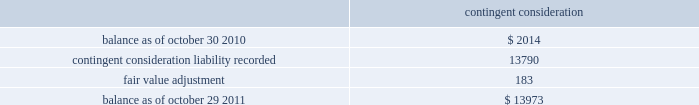( 2 ) the company has a master netting arrangement by counterparty with respect to derivative contracts .
As of october 29 , 2011 and october 30 , 2010 , contracts in a liability position of $ 0.8 million in each year , were netted against contracts in an asset position in the consolidated balance sheets .
( 3 ) equal to the accreted notional value of the debt plus the fair value of the interest rate component of the long- term debt .
The fair value of the long-term debt as of october 29 , 2011 and october 30 , 2010 was $ 413.4 million and $ 416.3 million , respectively .
The following methods and assumptions were used by the company in estimating its fair value disclosures for financial instruments : cash equivalents and short-term investments 2014 these investments are adjusted to fair value based on quoted market prices or are determined using a yield curve model based on current market rates .
Deferred compensation plan investments and other investments 2014 the fair value of these mutual fund , money market fund and equity investments are based on quoted market prices .
Long-term debt 2014 the fair value of long-term debt is based on quotes received from third-party banks .
Interest rate swap agreements 2014 the fair value of interest rate swap agreements is based on quotes received from third-party banks .
These values represent the estimated amount the company would receive or pay to terminate the agreements taking into consideration current interest rates as well as the creditworthiness of the counterparty .
Forward foreign currency exchange contracts 2014 the estimated fair value of forward foreign currency exchange contracts , which includes derivatives that are accounted for as cash flow hedges and those that are not designated as cash flow hedges , is based on the estimated amount the company would receive if it sold these agreements at the reporting date taking into consideration current interest rates as well as the creditworthiness of the counterparty for assets and the company 2019s creditworthiness for liabilities .
Contingent consideration 2014 the fair value of contingent consideration was estimated utilizing the income approach and is based upon significant inputs not observable in the market .
Changes in the fair value of the contingent consideration subsequent to the acquisition date that are primarily driven by assumptions pertaining to the achievement of the defined milestones will be recognized in operating income in the period of the estimated fair value change .
The table summarizes the change in the fair value of the contingent consideration measured using significant unobservable inputs ( level 3 ) for fiscal 2011 : contingent consideration .
Financial instruments not recorded at fair value on a recurring basis on april 4 , 2011 , the company issued $ 375 million aggregate principal amount of 3.0% ( 3.0 % ) senior unsecured notes due april 15 , 2016 ( the 3.0% ( 3.0 % ) notes ) with semi-annual fixed interest payments due on april 15 and october 15 of each year , commencing october 15 , 2011 .
The fair value of the 3.0% ( 3.0 % ) notes as of october 29 , 2011 was $ 392.8 million , based on quotes received from third-party banks .
Analog devices , inc .
Notes to consolidated financial statements 2014 ( continued ) .
What is the net change the fair value of the long-term debt in 2011? 
Computations: (413.4 - 416.3)
Answer: -2.9. 